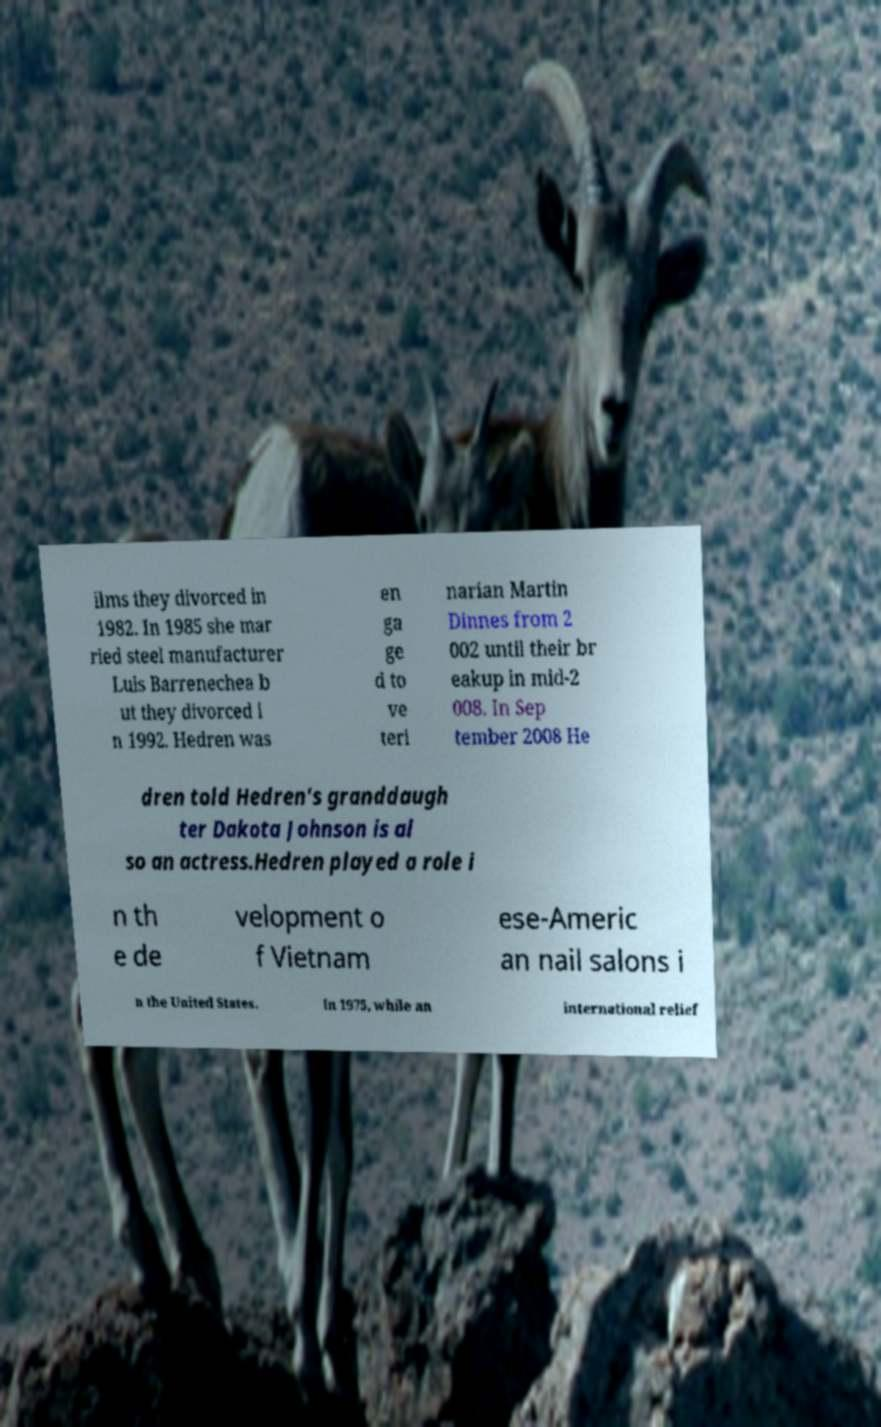Please identify and transcribe the text found in this image. ilms they divorced in 1982. In 1985 she mar ried steel manufacturer Luis Barrenechea b ut they divorced i n 1992. Hedren was en ga ge d to ve teri narian Martin Dinnes from 2 002 until their br eakup in mid-2 008. In Sep tember 2008 He dren told Hedren's granddaugh ter Dakota Johnson is al so an actress.Hedren played a role i n th e de velopment o f Vietnam ese-Americ an nail salons i n the United States. In 1975, while an international relief 